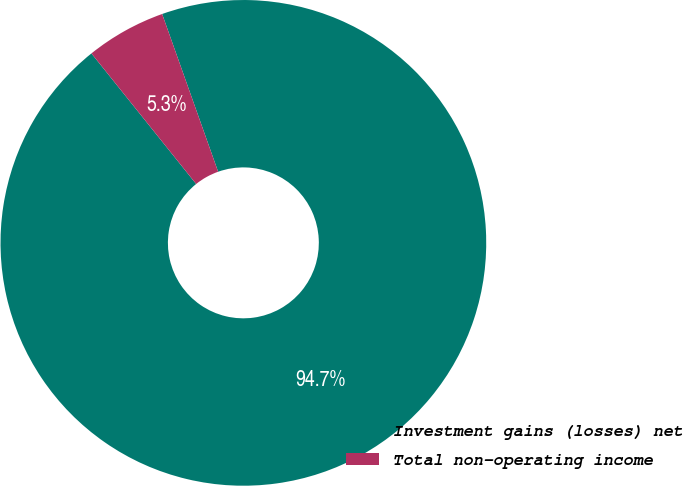Convert chart to OTSL. <chart><loc_0><loc_0><loc_500><loc_500><pie_chart><fcel>Investment gains (losses) net<fcel>Total non-operating income<nl><fcel>94.67%<fcel>5.33%<nl></chart> 